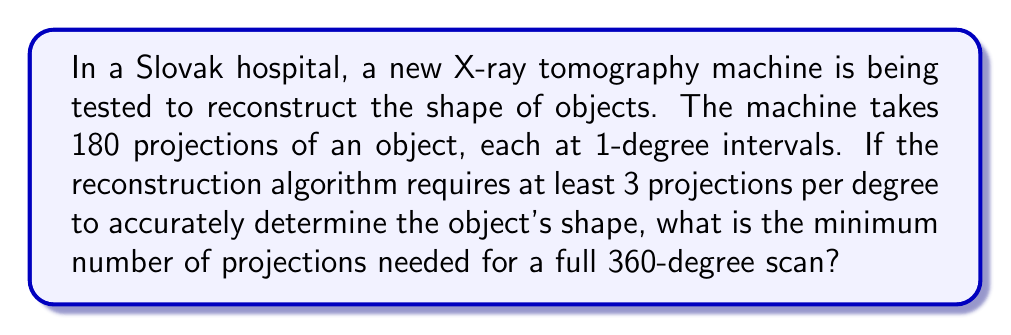Can you solve this math problem? To solve this problem, we need to follow these steps:

1. Understand the given information:
   - The current machine takes 180 projections at 1-degree intervals.
   - The algorithm requires at least 3 projections per degree for accurate reconstruction.

2. Calculate the number of projections needed for a full 360-degree scan:
   - Projections needed = Number of degrees × Projections per degree
   - $$\text{Projections needed} = 360° \times 3$$
   - $$\text{Projections needed} = 1080$$

3. Verify that this is indeed the minimum number:
   - Any fewer projections would result in less than 3 projections per degree, which would not meet the algorithm's requirements for accurate reconstruction.

Therefore, the minimum number of projections needed for a full 360-degree scan is 1080.
Answer: 1080 projections 